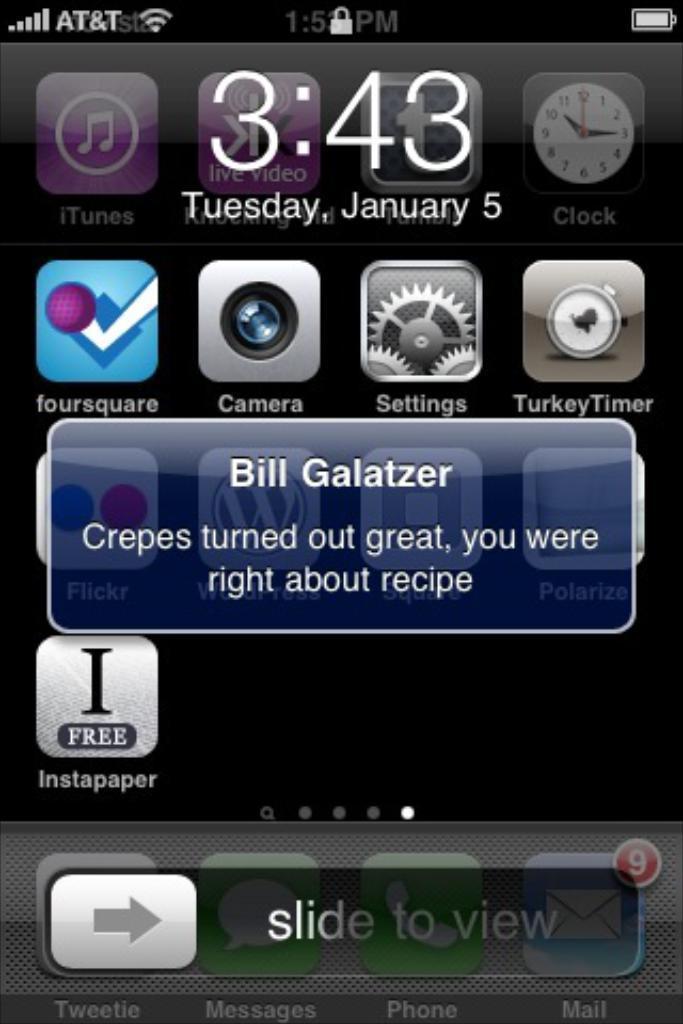Can you describe this image briefly? In this image we can see the screenshot of an iPhone where we can see icons, time and date, battery symbol and a message popped here. 